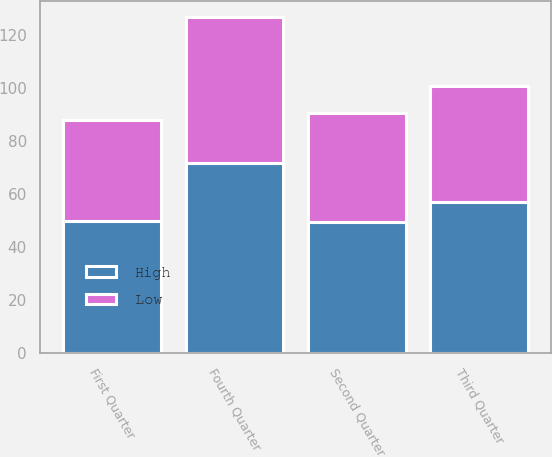Convert chart. <chart><loc_0><loc_0><loc_500><loc_500><stacked_bar_chart><ecel><fcel>First Quarter<fcel>Second Quarter<fcel>Third Quarter<fcel>Fourth Quarter<nl><fcel>High<fcel>49.9<fcel>49.58<fcel>57<fcel>71.85<nl><fcel>Low<fcel>38.02<fcel>41.2<fcel>43.69<fcel>54.84<nl></chart> 